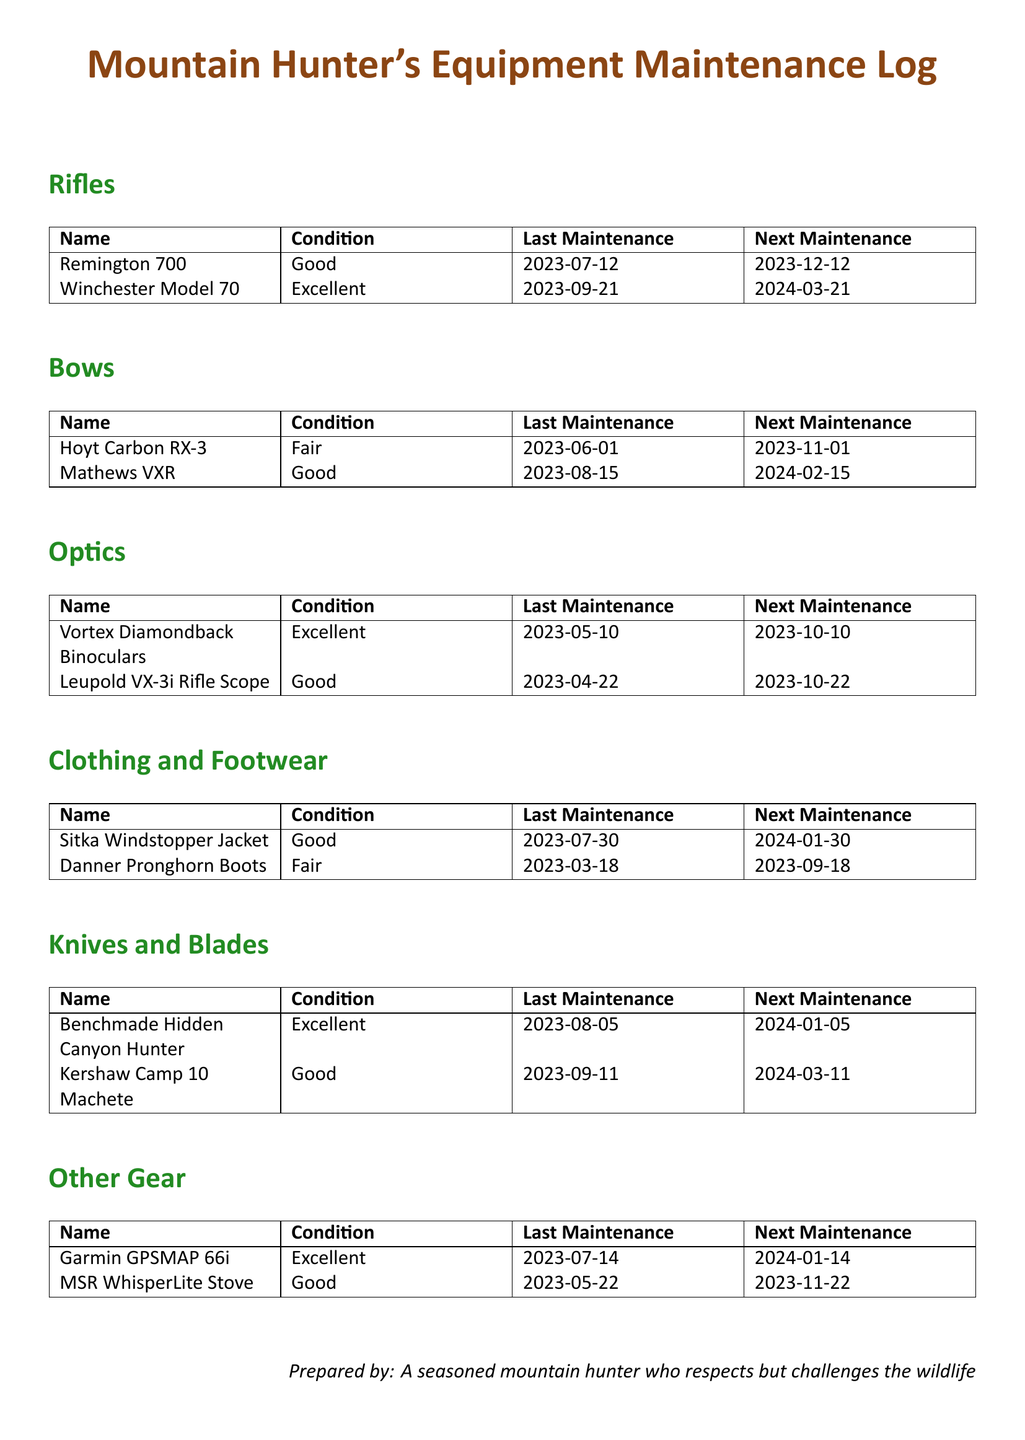what is the condition of the Remington 700? The condition of the Remington 700 is listed in the "Rifles" section of the document.
Answer: Good when is the next maintenance for the Hoyt Carbon RX-3? The next maintenance date for the Hoyt Carbon RX-3 is found in the "Bows" section.
Answer: 2023-11-01 how many knives are listed in the document? There is a count of items in the "Knives and Blades" section. There are two knives listed.
Answer: 2 which item has the last maintenance date of 2023-04-22? The "Optics" section lists items with their last maintenance dates, and the one with this date is identified.
Answer: Leupold VX-3i Rifle Scope when is the next maintenance for the Danner Pronghorn Boots? The next maintenance date can be found in the "Clothing and Footwear" section for this specific item.
Answer: 2023-09-18 what is the overall condition of the firearms listed? The conditions of the firearms are examined under the "Rifles" section.
Answer: Good and Excellent which item in the "Other Gear" section has its next maintenance due in January 2024? The "Other Gear" section lists items with their next maintenance dates, helping identify the specific item.
Answer: Garmin GPSMAP 66i which bow has a fair condition? The "Bows" section includes conditions of each bow, allowing for the identification of the one stated.
Answer: Hoyt Carbon RX-3 